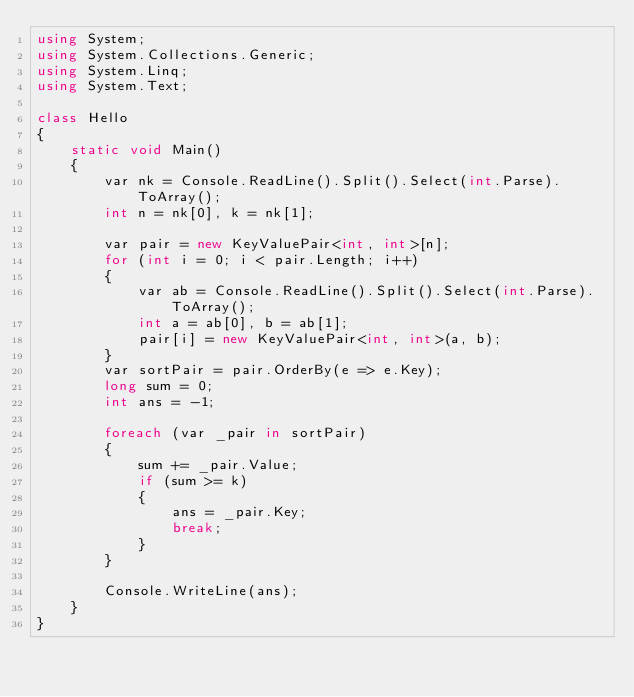<code> <loc_0><loc_0><loc_500><loc_500><_C#_>using System;
using System.Collections.Generic;
using System.Linq;
using System.Text;

class Hello
{
    static void Main()
    {
        var nk = Console.ReadLine().Split().Select(int.Parse).ToArray();
        int n = nk[0], k = nk[1];

        var pair = new KeyValuePair<int, int>[n];
        for (int i = 0; i < pair.Length; i++)
        {
            var ab = Console.ReadLine().Split().Select(int.Parse).ToArray();
            int a = ab[0], b = ab[1];
            pair[i] = new KeyValuePair<int, int>(a, b);
        }
        var sortPair = pair.OrderBy(e => e.Key);
        long sum = 0;
        int ans = -1;
        
        foreach (var _pair in sortPair)
        {
            sum += _pair.Value;
            if (sum >= k)
            {
                ans = _pair.Key;
                break;
            }
        }

        Console.WriteLine(ans);
    }
}</code> 